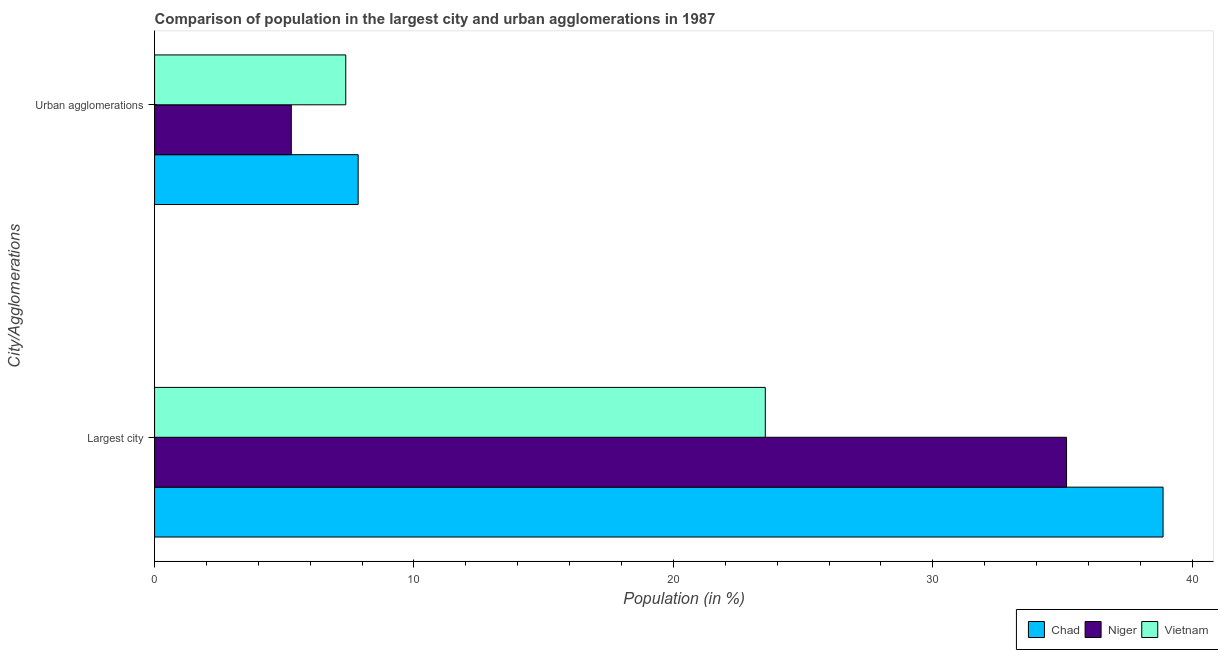Are the number of bars on each tick of the Y-axis equal?
Make the answer very short. Yes. How many bars are there on the 2nd tick from the bottom?
Keep it short and to the point. 3. What is the label of the 1st group of bars from the top?
Make the answer very short. Urban agglomerations. What is the population in urban agglomerations in Vietnam?
Your response must be concise. 7.37. Across all countries, what is the maximum population in urban agglomerations?
Ensure brevity in your answer.  7.85. Across all countries, what is the minimum population in the largest city?
Your response must be concise. 23.54. In which country was the population in the largest city maximum?
Make the answer very short. Chad. In which country was the population in urban agglomerations minimum?
Your answer should be compact. Niger. What is the total population in urban agglomerations in the graph?
Offer a terse response. 20.49. What is the difference between the population in the largest city in Niger and that in Chad?
Offer a terse response. -3.72. What is the difference between the population in the largest city in Chad and the population in urban agglomerations in Vietnam?
Your answer should be compact. 31.5. What is the average population in the largest city per country?
Your answer should be compact. 32.52. What is the difference between the population in the largest city and population in urban agglomerations in Chad?
Your answer should be very brief. 31.03. What is the ratio of the population in the largest city in Niger to that in Vietnam?
Make the answer very short. 1.49. In how many countries, is the population in the largest city greater than the average population in the largest city taken over all countries?
Provide a short and direct response. 2. What does the 3rd bar from the top in Urban agglomerations represents?
Ensure brevity in your answer.  Chad. What does the 2nd bar from the bottom in Largest city represents?
Make the answer very short. Niger. How many bars are there?
Give a very brief answer. 6. Are all the bars in the graph horizontal?
Offer a very short reply. Yes. How many countries are there in the graph?
Offer a terse response. 3. Are the values on the major ticks of X-axis written in scientific E-notation?
Your answer should be very brief. No. Does the graph contain any zero values?
Offer a terse response. No. Where does the legend appear in the graph?
Your answer should be compact. Bottom right. How many legend labels are there?
Make the answer very short. 3. How are the legend labels stacked?
Your answer should be very brief. Horizontal. What is the title of the graph?
Provide a succinct answer. Comparison of population in the largest city and urban agglomerations in 1987. Does "Nigeria" appear as one of the legend labels in the graph?
Your answer should be very brief. No. What is the label or title of the X-axis?
Your answer should be very brief. Population (in %). What is the label or title of the Y-axis?
Make the answer very short. City/Agglomerations. What is the Population (in %) of Chad in Largest city?
Provide a succinct answer. 38.87. What is the Population (in %) in Niger in Largest city?
Your answer should be compact. 35.15. What is the Population (in %) of Vietnam in Largest city?
Keep it short and to the point. 23.54. What is the Population (in %) in Chad in Urban agglomerations?
Provide a short and direct response. 7.85. What is the Population (in %) of Niger in Urban agglomerations?
Make the answer very short. 5.27. What is the Population (in %) of Vietnam in Urban agglomerations?
Your response must be concise. 7.37. Across all City/Agglomerations, what is the maximum Population (in %) in Chad?
Your response must be concise. 38.87. Across all City/Agglomerations, what is the maximum Population (in %) of Niger?
Make the answer very short. 35.15. Across all City/Agglomerations, what is the maximum Population (in %) in Vietnam?
Your answer should be very brief. 23.54. Across all City/Agglomerations, what is the minimum Population (in %) in Chad?
Provide a short and direct response. 7.85. Across all City/Agglomerations, what is the minimum Population (in %) in Niger?
Provide a succinct answer. 5.27. Across all City/Agglomerations, what is the minimum Population (in %) of Vietnam?
Give a very brief answer. 7.37. What is the total Population (in %) of Chad in the graph?
Provide a short and direct response. 46.72. What is the total Population (in %) of Niger in the graph?
Offer a terse response. 40.43. What is the total Population (in %) of Vietnam in the graph?
Provide a short and direct response. 30.91. What is the difference between the Population (in %) in Chad in Largest city and that in Urban agglomerations?
Keep it short and to the point. 31.03. What is the difference between the Population (in %) of Niger in Largest city and that in Urban agglomerations?
Give a very brief answer. 29.88. What is the difference between the Population (in %) in Vietnam in Largest city and that in Urban agglomerations?
Provide a short and direct response. 16.17. What is the difference between the Population (in %) in Chad in Largest city and the Population (in %) in Niger in Urban agglomerations?
Your response must be concise. 33.6. What is the difference between the Population (in %) of Chad in Largest city and the Population (in %) of Vietnam in Urban agglomerations?
Make the answer very short. 31.5. What is the difference between the Population (in %) in Niger in Largest city and the Population (in %) in Vietnam in Urban agglomerations?
Offer a very short reply. 27.78. What is the average Population (in %) in Chad per City/Agglomerations?
Provide a short and direct response. 23.36. What is the average Population (in %) in Niger per City/Agglomerations?
Offer a very short reply. 20.21. What is the average Population (in %) in Vietnam per City/Agglomerations?
Ensure brevity in your answer.  15.46. What is the difference between the Population (in %) in Chad and Population (in %) in Niger in Largest city?
Ensure brevity in your answer.  3.72. What is the difference between the Population (in %) of Chad and Population (in %) of Vietnam in Largest city?
Give a very brief answer. 15.33. What is the difference between the Population (in %) in Niger and Population (in %) in Vietnam in Largest city?
Provide a short and direct response. 11.61. What is the difference between the Population (in %) in Chad and Population (in %) in Niger in Urban agglomerations?
Provide a short and direct response. 2.58. What is the difference between the Population (in %) of Chad and Population (in %) of Vietnam in Urban agglomerations?
Give a very brief answer. 0.48. What is the difference between the Population (in %) in Niger and Population (in %) in Vietnam in Urban agglomerations?
Provide a succinct answer. -2.1. What is the ratio of the Population (in %) in Chad in Largest city to that in Urban agglomerations?
Offer a terse response. 4.95. What is the ratio of the Population (in %) of Niger in Largest city to that in Urban agglomerations?
Your response must be concise. 6.67. What is the ratio of the Population (in %) in Vietnam in Largest city to that in Urban agglomerations?
Your answer should be very brief. 3.19. What is the difference between the highest and the second highest Population (in %) of Chad?
Make the answer very short. 31.03. What is the difference between the highest and the second highest Population (in %) in Niger?
Your answer should be compact. 29.88. What is the difference between the highest and the second highest Population (in %) in Vietnam?
Give a very brief answer. 16.17. What is the difference between the highest and the lowest Population (in %) in Chad?
Offer a terse response. 31.03. What is the difference between the highest and the lowest Population (in %) of Niger?
Provide a succinct answer. 29.88. What is the difference between the highest and the lowest Population (in %) of Vietnam?
Provide a short and direct response. 16.17. 